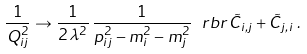<formula> <loc_0><loc_0><loc_500><loc_500>\frac { 1 } { Q _ { i j } ^ { 2 } } \to \frac { 1 } { 2 \, \lambda ^ { 2 } } \, \frac { 1 } { p _ { i j } ^ { \, 2 } - m _ { i } ^ { 2 } - m _ { j } ^ { 2 } } \, \ r b r { \, \tilde { C } _ { i , j } + \tilde { C } _ { j , i } \, } \, .</formula> 